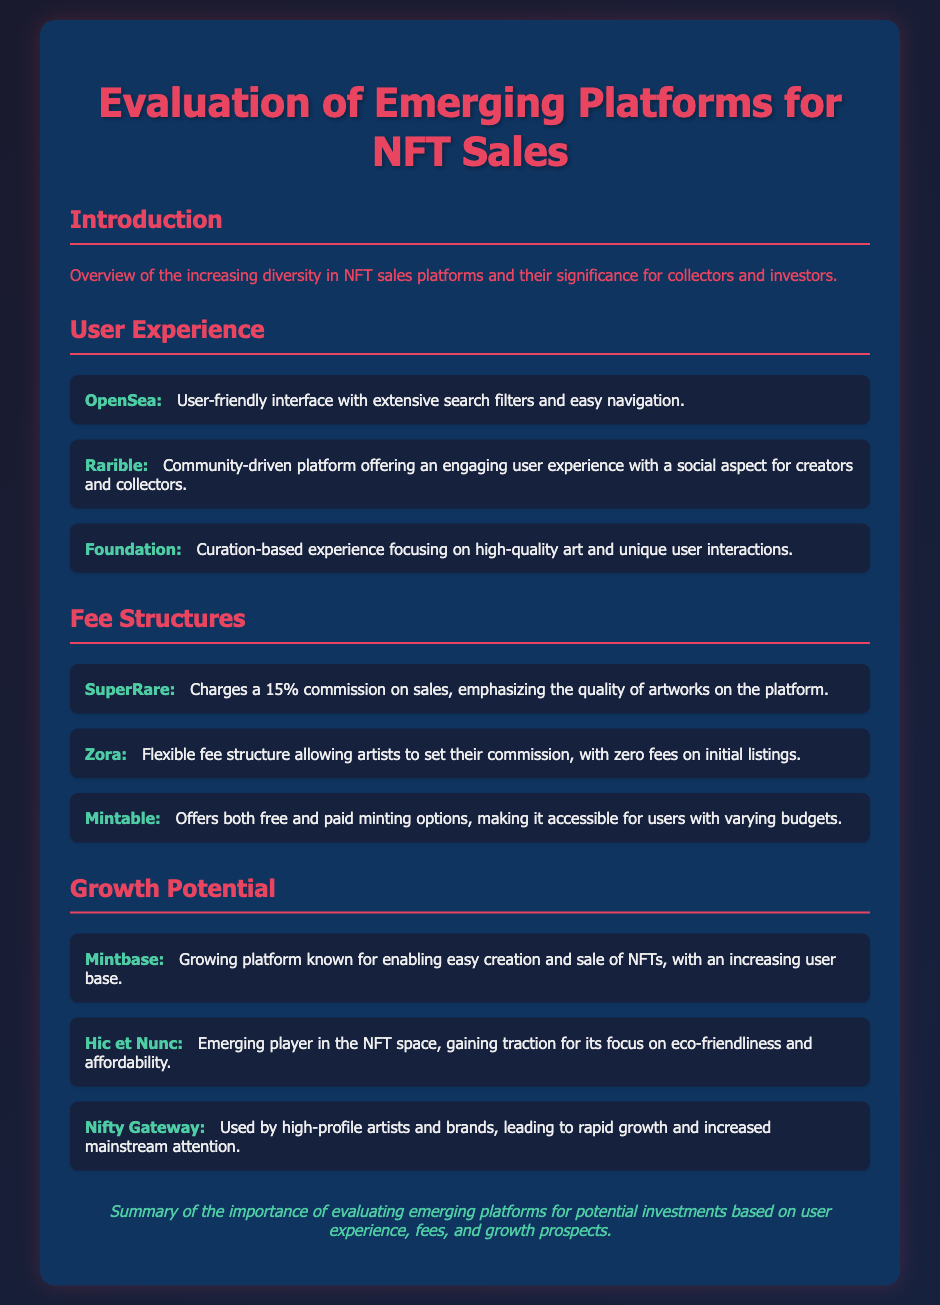What is the title of the document? The title is specified in the document header.
Answer: Evaluation of Emerging Platforms for NFT Sales Which platform charges a 15% commission? The commission structure for different platforms is outlined under the fee structures section.
Answer: SuperRare What type of user experience does Rarible offer? The user experience characteristics for each platform are described in the user experience section.
Answer: Community-driven What is the focus of Hic et Nunc? The growth potential section describes the focus of various platforms.
Answer: Eco-friendliness and affordability How many platforms are listed under User Experience? The number of platforms can be counted from the list in the user experience section.
Answer: Three Which platform allows artists to set their commission? The fee structure section lists specific platforms and their fee policies.
Answer: Zora What is the main characteristic of Foundation? Each platform's unique attributes are outlined in the user experience section.
Answer: Curation-based experience What does Mintbase enable? The growth potential section describes the functions and capabilities of various platforms.
Answer: Easy creation and sale of NFTs 